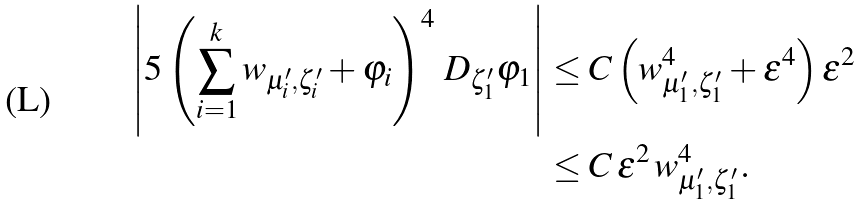<formula> <loc_0><loc_0><loc_500><loc_500>\left | 5 \left ( \sum _ { i = 1 } ^ { k } w _ { \mu _ { i } ^ { \prime } , \zeta _ { i } ^ { \prime } } + \varphi _ { i } \right ) ^ { 4 } \, D _ { \zeta _ { 1 } ^ { \prime } } \varphi _ { 1 } \right | & \leq C \left ( w _ { \mu _ { 1 } ^ { \prime } , \zeta _ { 1 } ^ { \prime } } ^ { 4 } + \varepsilon ^ { 4 } \right ) \varepsilon ^ { 2 } \\ & \leq C \, \varepsilon ^ { 2 } \, w _ { \mu _ { 1 } ^ { \prime } , \zeta _ { 1 } ^ { \prime } } ^ { 4 } .</formula> 